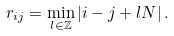<formula> <loc_0><loc_0><loc_500><loc_500>r _ { i j } = \min _ { l \in \mathbb { Z } } \left | i - j + l N \right | .</formula> 